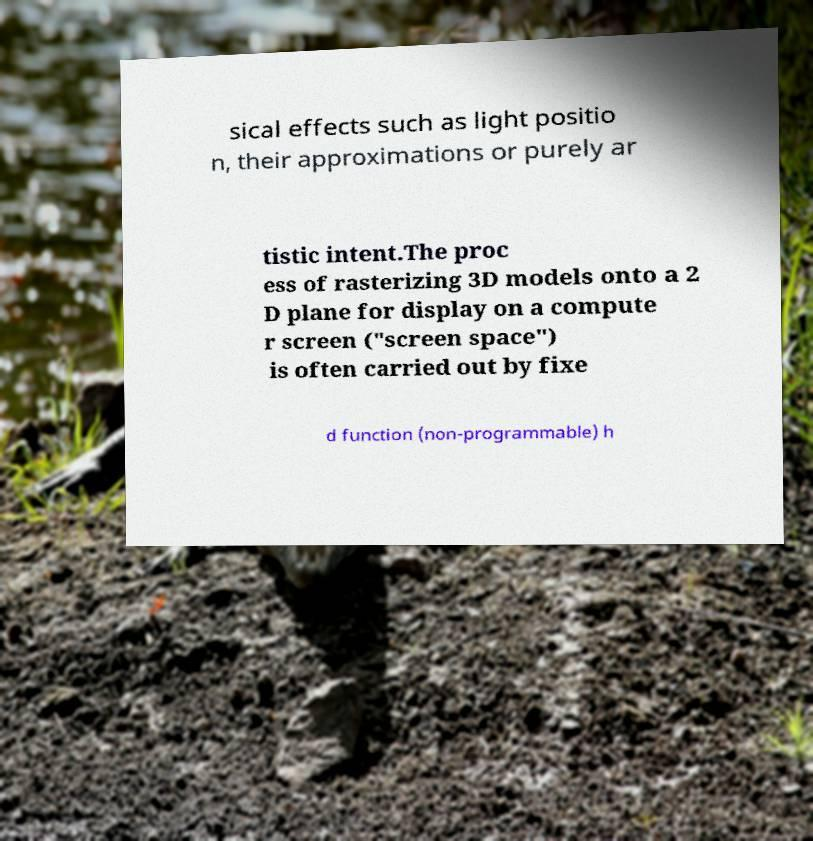For documentation purposes, I need the text within this image transcribed. Could you provide that? sical effects such as light positio n, their approximations or purely ar tistic intent.The proc ess of rasterizing 3D models onto a 2 D plane for display on a compute r screen ("screen space") is often carried out by fixe d function (non-programmable) h 